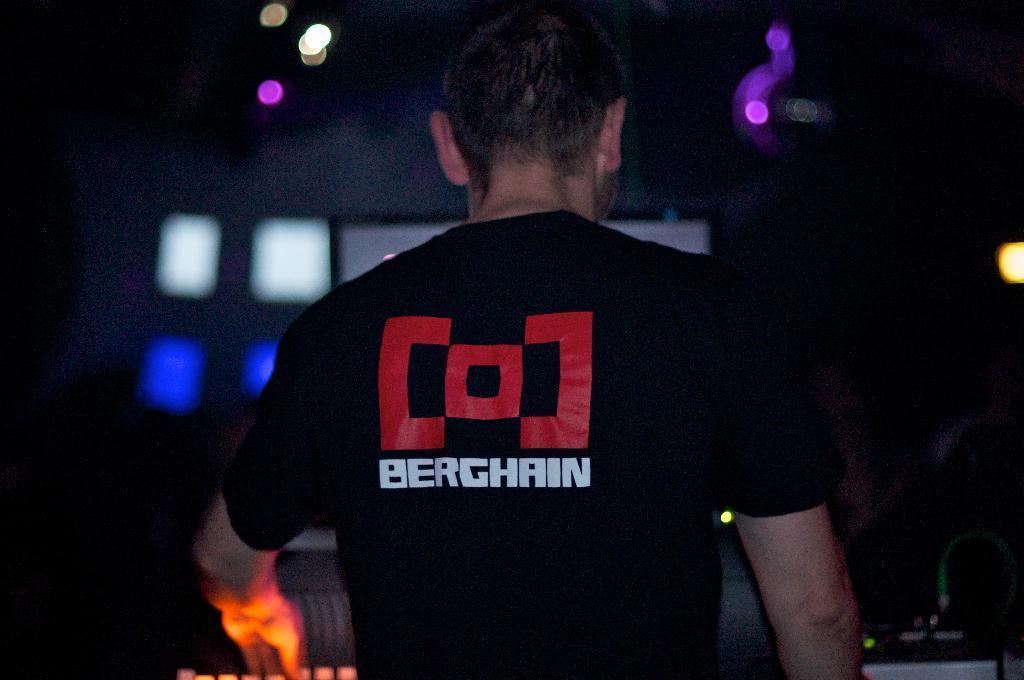Describe this image in one or two sentences. In this picture we can see a man and in the background we can see lights and it is dark. 